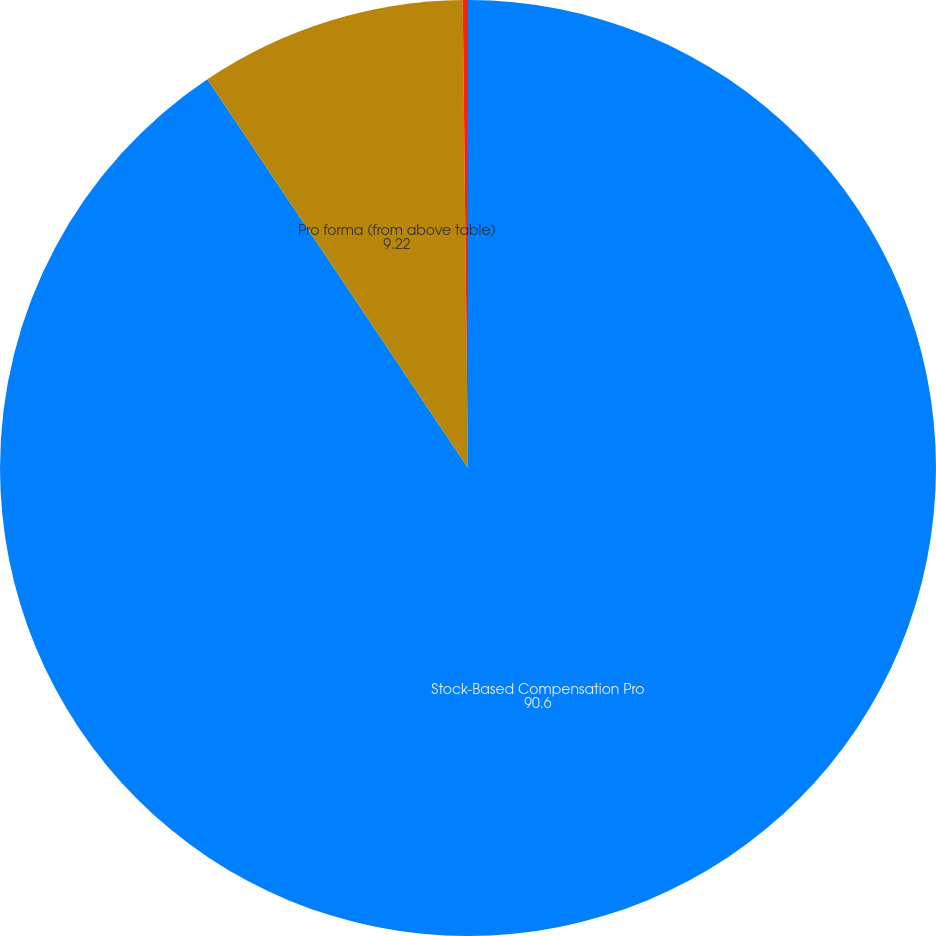Convert chart. <chart><loc_0><loc_0><loc_500><loc_500><pie_chart><fcel>Stock-Based Compensation Pro<fcel>Pro forma (from above table)<fcel>Pro forma (adjusted to reflect<nl><fcel>90.6%<fcel>9.22%<fcel>0.18%<nl></chart> 